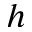Convert formula to latex. <formula><loc_0><loc_0><loc_500><loc_500>h</formula> 